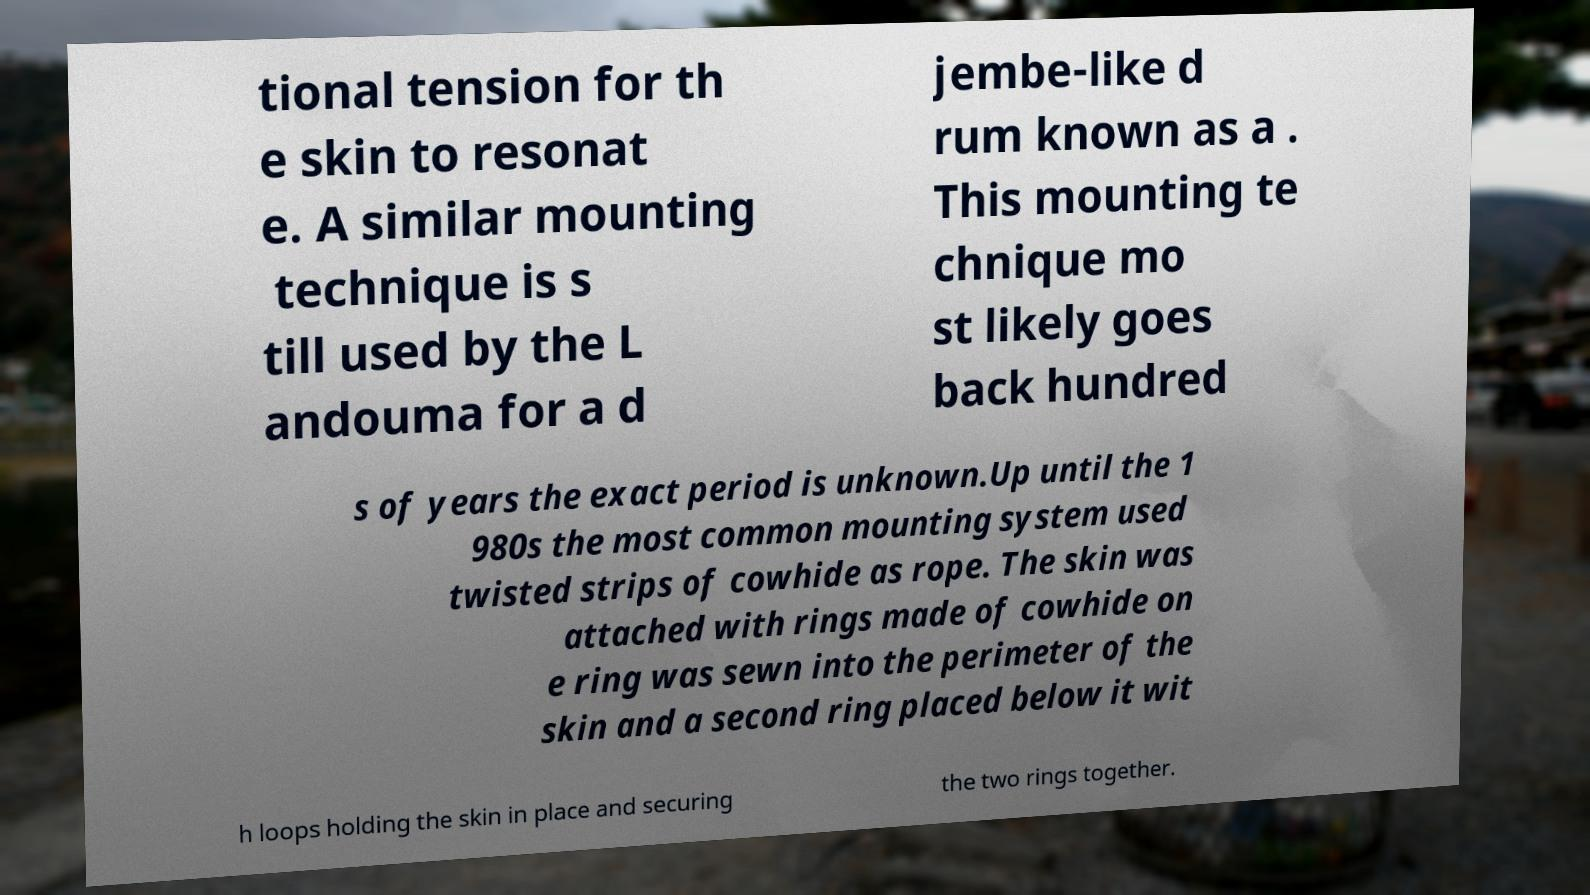I need the written content from this picture converted into text. Can you do that? tional tension for th e skin to resonat e. A similar mounting technique is s till used by the L andouma for a d jembe-like d rum known as a . This mounting te chnique mo st likely goes back hundred s of years the exact period is unknown.Up until the 1 980s the most common mounting system used twisted strips of cowhide as rope. The skin was attached with rings made of cowhide on e ring was sewn into the perimeter of the skin and a second ring placed below it wit h loops holding the skin in place and securing the two rings together. 